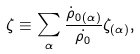Convert formula to latex. <formula><loc_0><loc_0><loc_500><loc_500>\zeta \equiv \sum _ { \alpha } \frac { \dot { \rho } _ { 0 ( \alpha ) } } { \dot { \rho _ { 0 } } } \zeta _ { ( \alpha ) } ,</formula> 